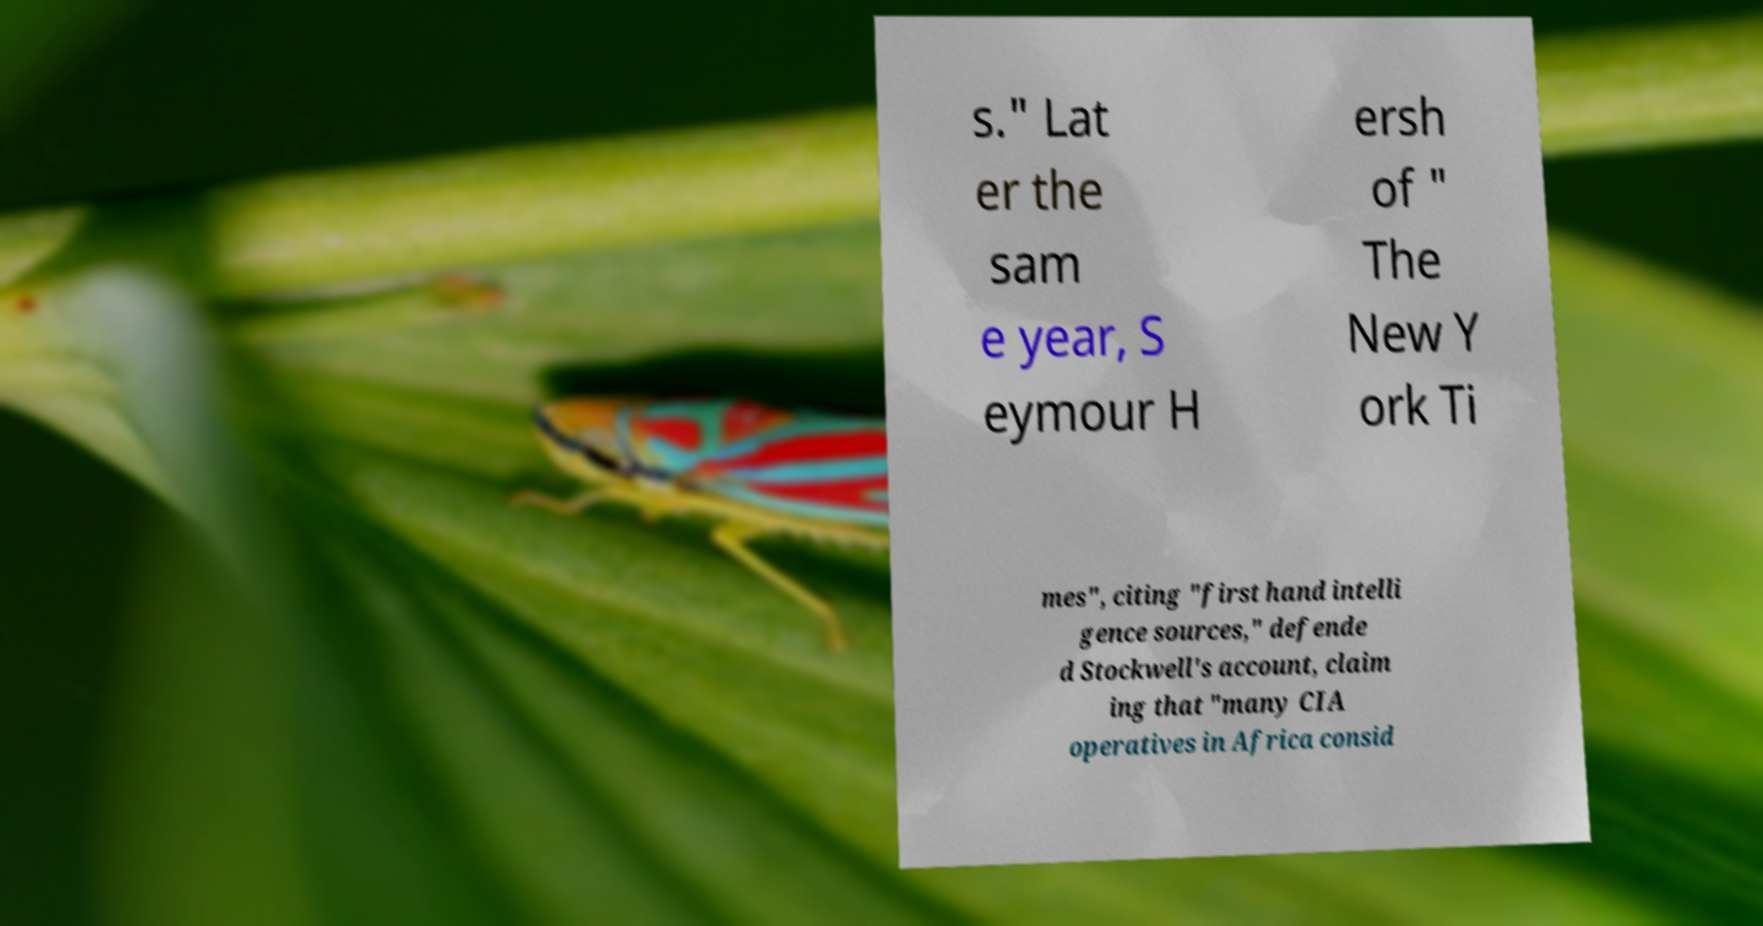What messages or text are displayed in this image? I need them in a readable, typed format. s." Lat er the sam e year, S eymour H ersh of " The New Y ork Ti mes", citing "first hand intelli gence sources," defende d Stockwell's account, claim ing that "many CIA operatives in Africa consid 